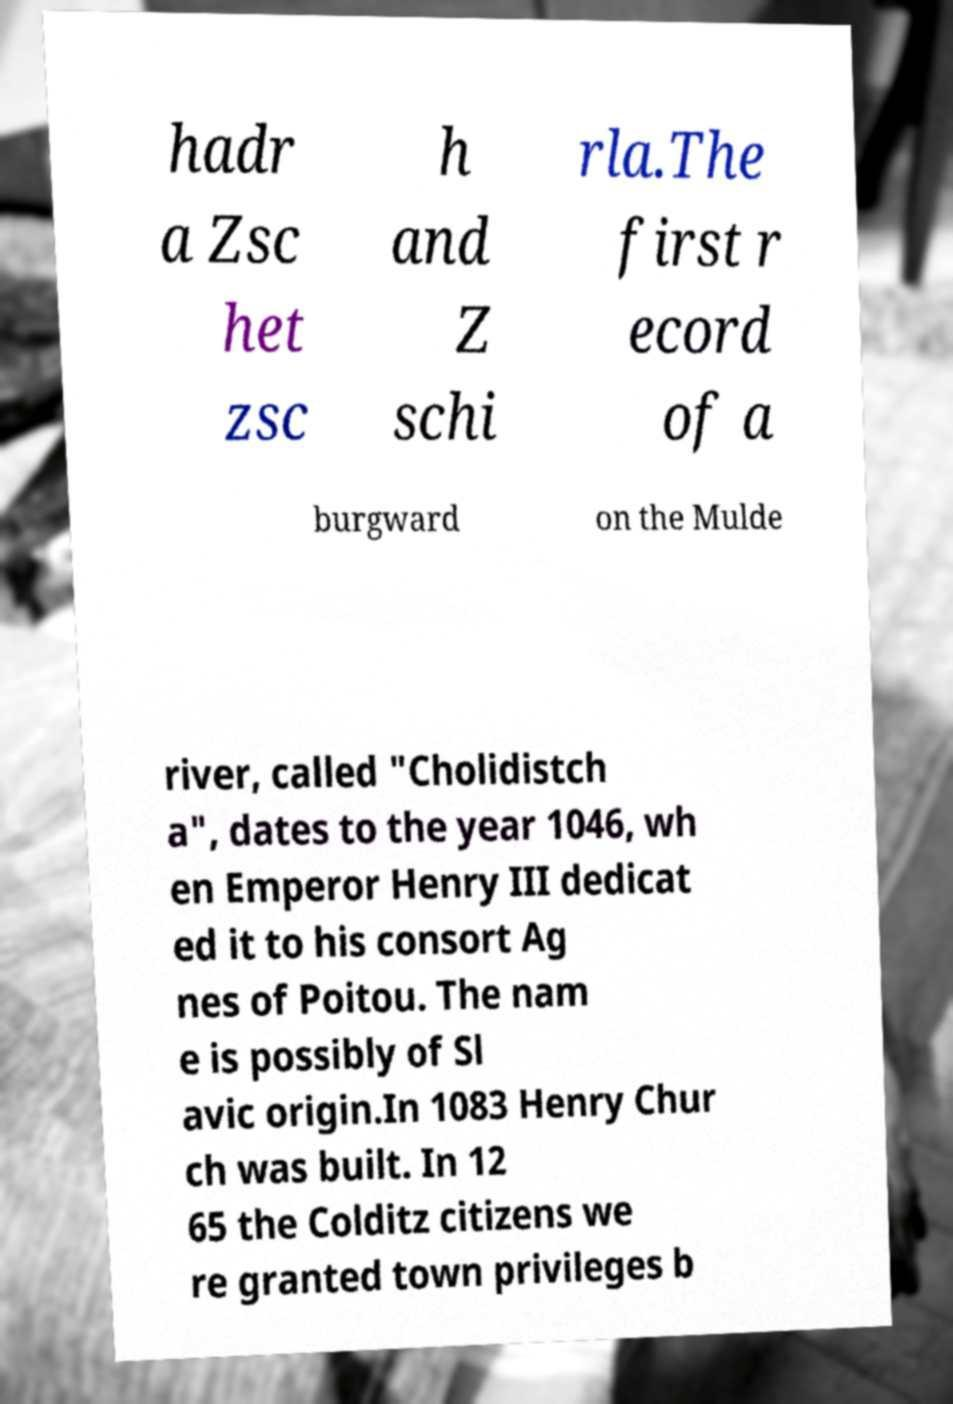Could you assist in decoding the text presented in this image and type it out clearly? hadr a Zsc het zsc h and Z schi rla.The first r ecord of a burgward on the Mulde river, called "Cholidistch a", dates to the year 1046, wh en Emperor Henry III dedicat ed it to his consort Ag nes of Poitou. The nam e is possibly of Sl avic origin.In 1083 Henry Chur ch was built. In 12 65 the Colditz citizens we re granted town privileges b 